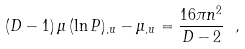<formula> <loc_0><loc_0><loc_500><loc_500>( D - 1 ) \, \mu \, ( \ln P ) _ { , u } - \mu _ { , u } = \frac { 1 6 \pi n ^ { 2 } } { D - 2 } \ ,</formula> 